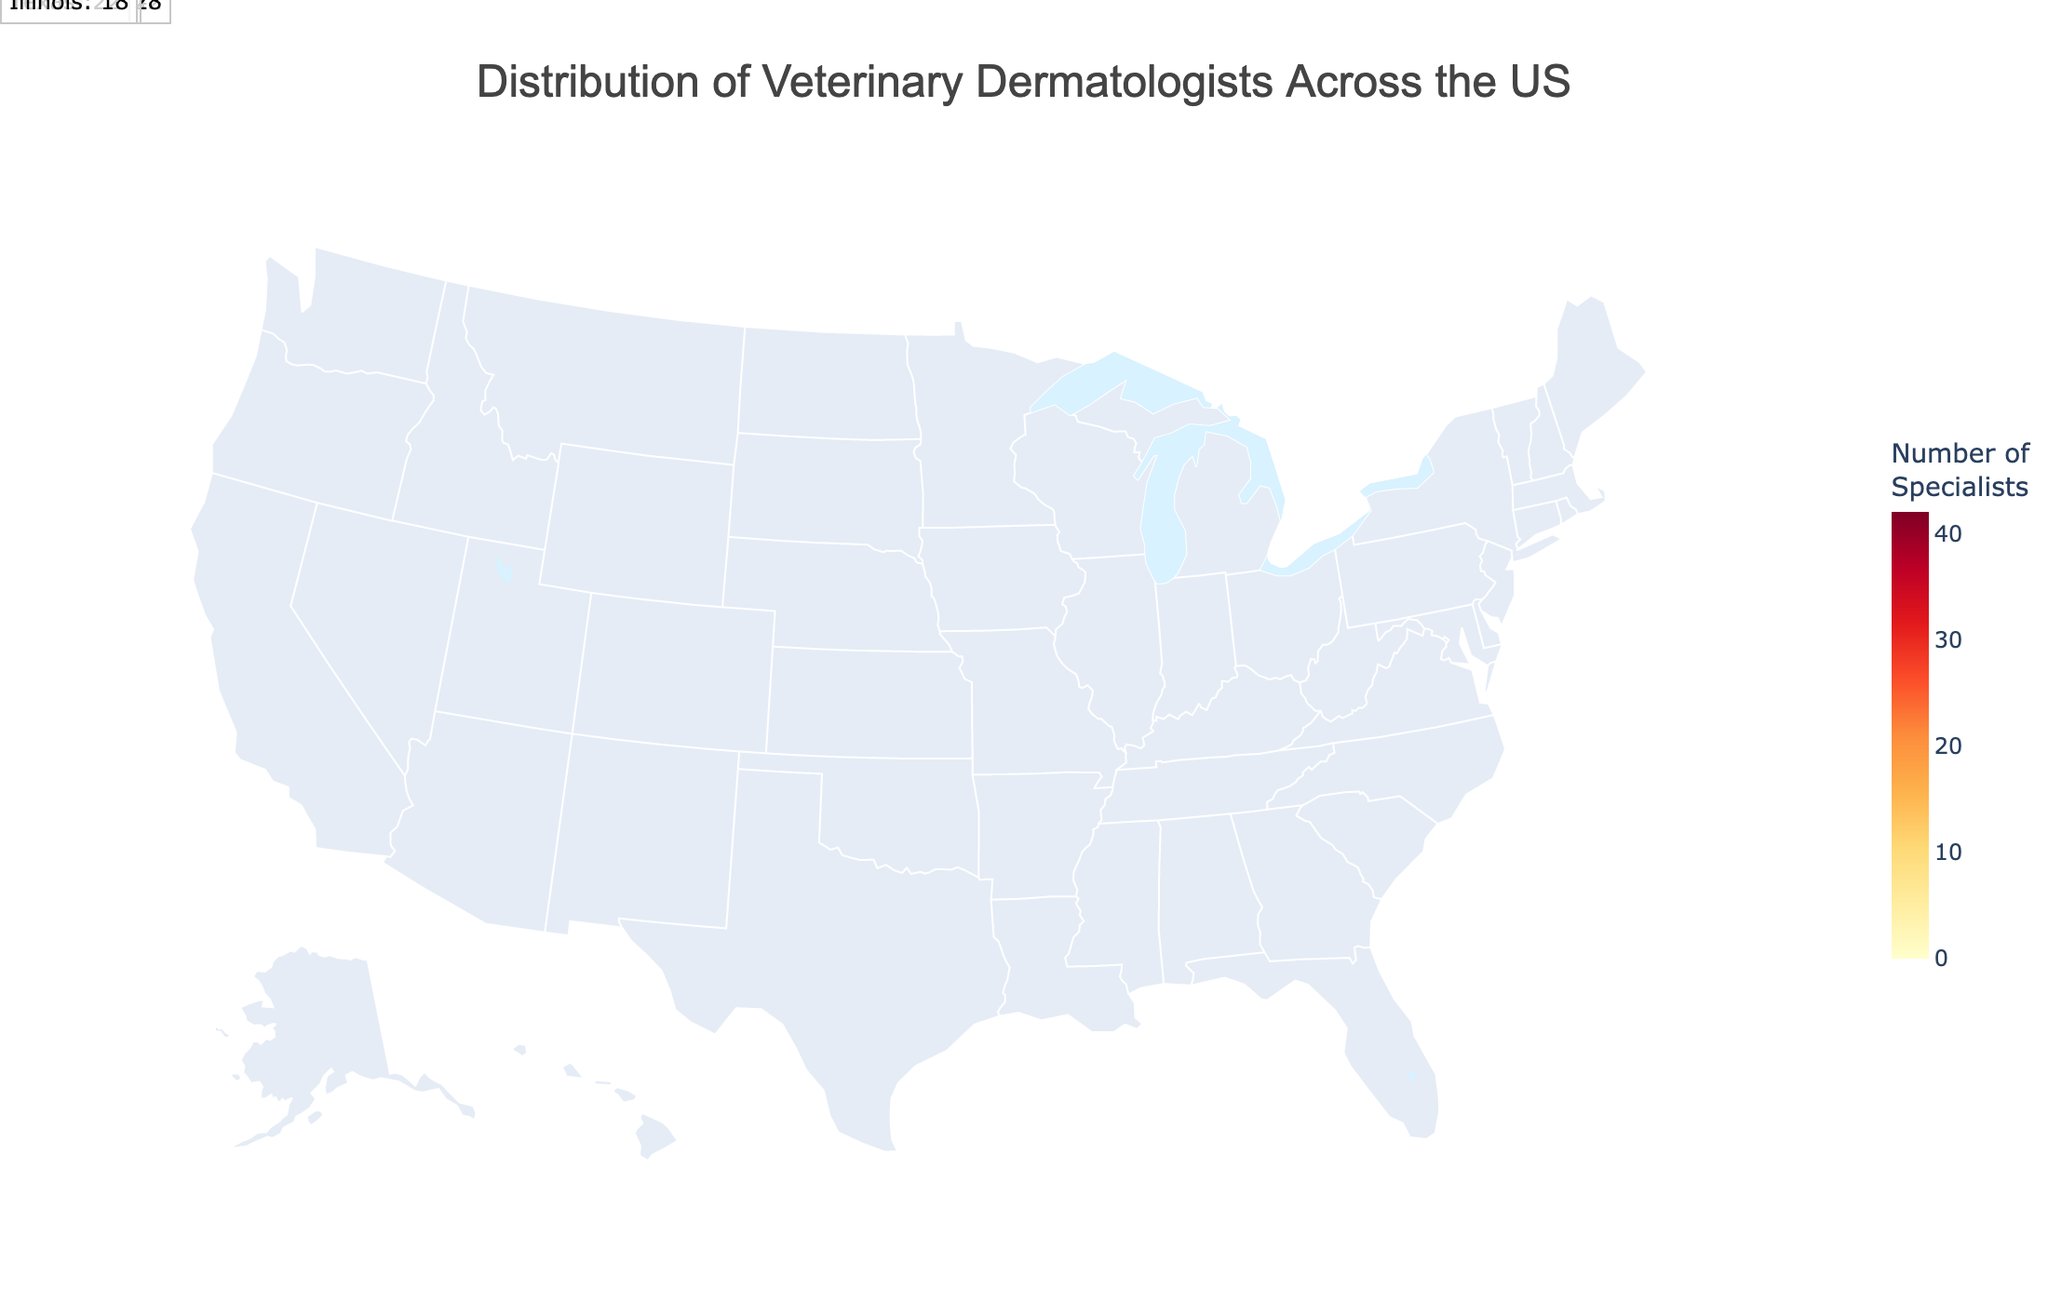What's the title of the figure? The title is usually positioned at the top and is written prominently. In this figure, the title is shown at the top and specifies the content being displayed.
Answer: Distribution of Veterinary Dermatologists Across the US Which state has the highest number of veterinary dermatologists? The state with the highest number of veterinary dermatologists will be highlighted in the darkest color and will have the highest numerical value attached to it. California is represented with the highest number.
Answer: California How many veterinary dermatologists are in Texas? By looking at the numeric value associated with Texas on the map, you can see that Texas has a specific number of specialists.
Answer: 22 Compare the number of veterinary dermatologists in New York and Florida. Which state has more? To compare New York and Florida, you can check the numeric values next to each state. New York has 28 and Florida has 25.
Answer: New York What is the total number of veterinary dermatologists in the top 5 states? Sum up the numbers of veterinary dermatologists from the top five states (California, New York, Florida, Texas, Illinois): 42 + 28 + 25 + 22 + 18 = 135.
Answer: 135 Which state has the least number of veterinary dermatologists, and how many are there? States with the least number will have the lowest numbers and the lightest colors. There are multiple states with the minimum number, which is 1.
Answer: Multiple states with 1 (e.g., Alabama, Connecticut, Kansas, etc.) How does the number of veterinary dermatologists in Ohio compare to that in Michigan? By looking at their respective numbers, Ohio has 12 and Michigan has 7. Ohio has more.
Answer: Ohio What is the total number of veterinary dermatologists in the US, based on the figure? To find the total, add the numbers from all states: 42 + 28 + 25 + 22 + 18 + 15 + 14 + 12 + 11 + 10 + 9 + 8 + 8 + 7 + 7 + 6 + 5 + 5 + 4 + 4 + 3 + 3 + 2 + 2 + 2 + 2 + 1 + 1 + 1 + 1 + 1 + 1 = 268.
Answer: 268 Which states fall within the mid-range (neither the highest nor the lowest) of the number of veterinary dermatologists? States that are not at the extremes can be identified by the in-between color shades and numbers. Examples are Virginia, Colorado, and Arizona.
Answer: Virginia, Colorado, Arizona How many states have less than 5 veterinary dermatologists? Count the states where the number of specialists is less than 5. Listing those states: Maryland, Tennessee, Indiana, Kentucky, Louisiana, South Carolina, Alabama, Connecticut, Kansas, Nevada, Oklahoma, Utah.
Answer: 12 states 